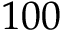<formula> <loc_0><loc_0><loc_500><loc_500>1 0 0</formula> 